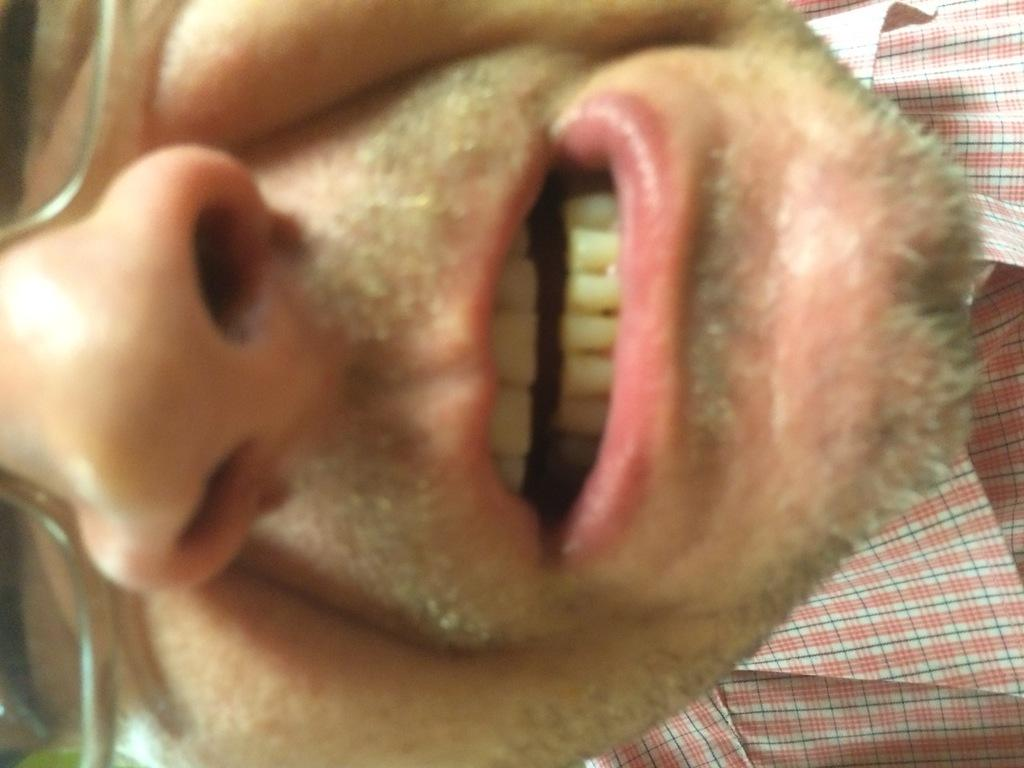Who is present in the image? There is a man in the image. What is the man wearing on his face? The man is wearing spectacles. How many chickens are present in the image? There are no chickens present in the image; it only features a man wearing spectacles. 